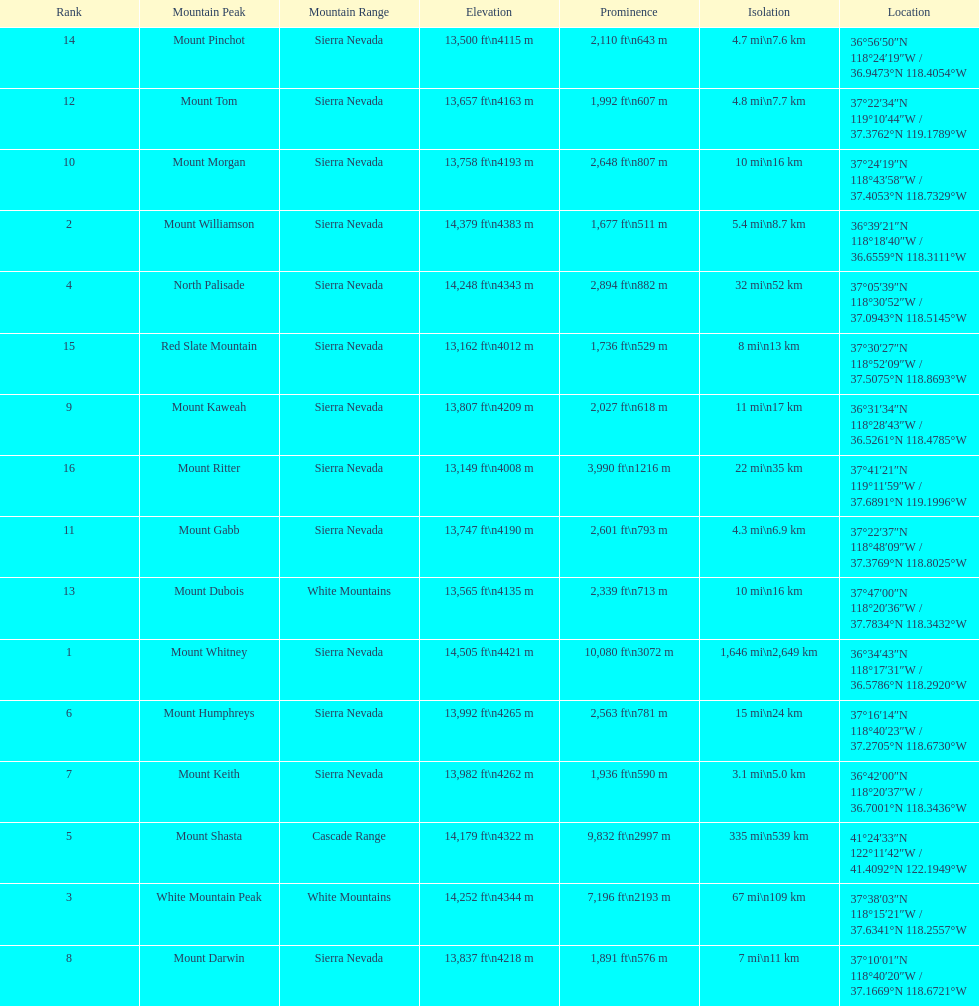Which mountain peak has a prominence more than 10,000 ft? Mount Whitney. 